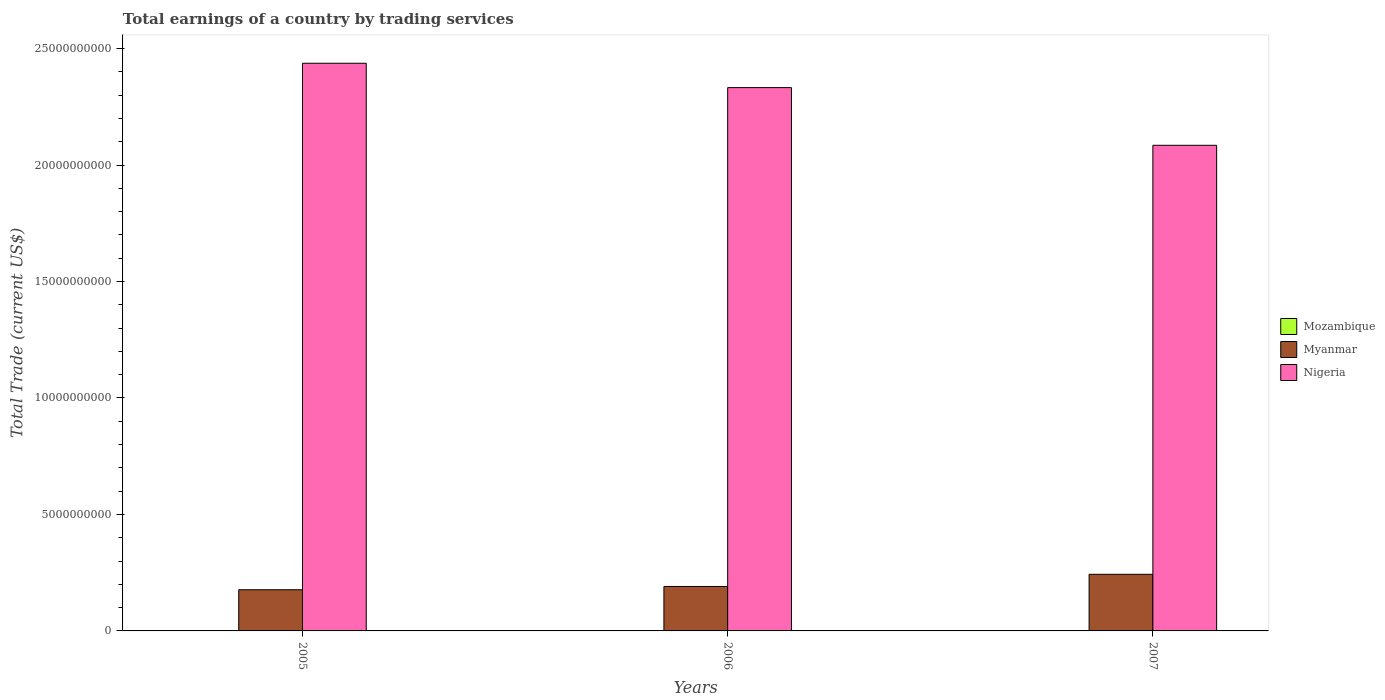How many different coloured bars are there?
Provide a succinct answer. 2. Are the number of bars per tick equal to the number of legend labels?
Provide a succinct answer. No. In how many cases, is the number of bars for a given year not equal to the number of legend labels?
Your response must be concise. 3. What is the total earnings in Myanmar in 2007?
Provide a short and direct response. 2.43e+09. Across all years, what is the maximum total earnings in Myanmar?
Make the answer very short. 2.43e+09. Across all years, what is the minimum total earnings in Myanmar?
Provide a short and direct response. 1.77e+09. In which year was the total earnings in Nigeria maximum?
Provide a succinct answer. 2005. What is the total total earnings in Myanmar in the graph?
Your response must be concise. 6.11e+09. What is the difference between the total earnings in Myanmar in 2005 and that in 2006?
Offer a terse response. -1.41e+08. What is the difference between the total earnings in Mozambique in 2007 and the total earnings in Myanmar in 2006?
Your response must be concise. -1.91e+09. What is the average total earnings in Myanmar per year?
Keep it short and to the point. 2.04e+09. In the year 2006, what is the difference between the total earnings in Nigeria and total earnings in Myanmar?
Provide a short and direct response. 2.14e+1. What is the ratio of the total earnings in Nigeria in 2006 to that in 2007?
Provide a succinct answer. 1.12. Is the total earnings in Nigeria in 2005 less than that in 2007?
Provide a short and direct response. No. Is the difference between the total earnings in Nigeria in 2005 and 2007 greater than the difference between the total earnings in Myanmar in 2005 and 2007?
Provide a succinct answer. Yes. What is the difference between the highest and the second highest total earnings in Myanmar?
Your answer should be very brief. 5.22e+08. What is the difference between the highest and the lowest total earnings in Myanmar?
Your answer should be compact. 6.63e+08. In how many years, is the total earnings in Nigeria greater than the average total earnings in Nigeria taken over all years?
Provide a succinct answer. 2. Is it the case that in every year, the sum of the total earnings in Myanmar and total earnings in Mozambique is greater than the total earnings in Nigeria?
Provide a short and direct response. No. How many bars are there?
Provide a short and direct response. 6. How many years are there in the graph?
Offer a terse response. 3. Are the values on the major ticks of Y-axis written in scientific E-notation?
Offer a very short reply. No. Does the graph contain any zero values?
Your answer should be very brief. Yes. What is the title of the graph?
Offer a terse response. Total earnings of a country by trading services. What is the label or title of the Y-axis?
Make the answer very short. Total Trade (current US$). What is the Total Trade (current US$) in Myanmar in 2005?
Provide a succinct answer. 1.77e+09. What is the Total Trade (current US$) in Nigeria in 2005?
Your response must be concise. 2.44e+1. What is the Total Trade (current US$) in Mozambique in 2006?
Provide a short and direct response. 0. What is the Total Trade (current US$) of Myanmar in 2006?
Provide a succinct answer. 1.91e+09. What is the Total Trade (current US$) of Nigeria in 2006?
Give a very brief answer. 2.33e+1. What is the Total Trade (current US$) of Mozambique in 2007?
Keep it short and to the point. 0. What is the Total Trade (current US$) in Myanmar in 2007?
Ensure brevity in your answer.  2.43e+09. What is the Total Trade (current US$) of Nigeria in 2007?
Keep it short and to the point. 2.08e+1. Across all years, what is the maximum Total Trade (current US$) of Myanmar?
Ensure brevity in your answer.  2.43e+09. Across all years, what is the maximum Total Trade (current US$) of Nigeria?
Provide a succinct answer. 2.44e+1. Across all years, what is the minimum Total Trade (current US$) of Myanmar?
Provide a succinct answer. 1.77e+09. Across all years, what is the minimum Total Trade (current US$) of Nigeria?
Make the answer very short. 2.08e+1. What is the total Total Trade (current US$) in Myanmar in the graph?
Your answer should be compact. 6.11e+09. What is the total Total Trade (current US$) in Nigeria in the graph?
Offer a terse response. 6.85e+1. What is the difference between the Total Trade (current US$) in Myanmar in 2005 and that in 2006?
Offer a terse response. -1.41e+08. What is the difference between the Total Trade (current US$) of Nigeria in 2005 and that in 2006?
Make the answer very short. 1.05e+09. What is the difference between the Total Trade (current US$) of Myanmar in 2005 and that in 2007?
Make the answer very short. -6.63e+08. What is the difference between the Total Trade (current US$) in Nigeria in 2005 and that in 2007?
Your answer should be compact. 3.52e+09. What is the difference between the Total Trade (current US$) of Myanmar in 2006 and that in 2007?
Give a very brief answer. -5.22e+08. What is the difference between the Total Trade (current US$) of Nigeria in 2006 and that in 2007?
Ensure brevity in your answer.  2.48e+09. What is the difference between the Total Trade (current US$) of Myanmar in 2005 and the Total Trade (current US$) of Nigeria in 2006?
Keep it short and to the point. -2.16e+1. What is the difference between the Total Trade (current US$) of Myanmar in 2005 and the Total Trade (current US$) of Nigeria in 2007?
Ensure brevity in your answer.  -1.91e+1. What is the difference between the Total Trade (current US$) of Myanmar in 2006 and the Total Trade (current US$) of Nigeria in 2007?
Provide a short and direct response. -1.89e+1. What is the average Total Trade (current US$) in Myanmar per year?
Keep it short and to the point. 2.04e+09. What is the average Total Trade (current US$) of Nigeria per year?
Your response must be concise. 2.28e+1. In the year 2005, what is the difference between the Total Trade (current US$) of Myanmar and Total Trade (current US$) of Nigeria?
Provide a short and direct response. -2.26e+1. In the year 2006, what is the difference between the Total Trade (current US$) of Myanmar and Total Trade (current US$) of Nigeria?
Your answer should be very brief. -2.14e+1. In the year 2007, what is the difference between the Total Trade (current US$) in Myanmar and Total Trade (current US$) in Nigeria?
Your answer should be compact. -1.84e+1. What is the ratio of the Total Trade (current US$) in Myanmar in 2005 to that in 2006?
Provide a short and direct response. 0.93. What is the ratio of the Total Trade (current US$) in Nigeria in 2005 to that in 2006?
Give a very brief answer. 1.04. What is the ratio of the Total Trade (current US$) of Myanmar in 2005 to that in 2007?
Make the answer very short. 0.73. What is the ratio of the Total Trade (current US$) of Nigeria in 2005 to that in 2007?
Offer a very short reply. 1.17. What is the ratio of the Total Trade (current US$) of Myanmar in 2006 to that in 2007?
Offer a very short reply. 0.79. What is the ratio of the Total Trade (current US$) in Nigeria in 2006 to that in 2007?
Keep it short and to the point. 1.12. What is the difference between the highest and the second highest Total Trade (current US$) of Myanmar?
Offer a very short reply. 5.22e+08. What is the difference between the highest and the second highest Total Trade (current US$) of Nigeria?
Provide a short and direct response. 1.05e+09. What is the difference between the highest and the lowest Total Trade (current US$) in Myanmar?
Give a very brief answer. 6.63e+08. What is the difference between the highest and the lowest Total Trade (current US$) in Nigeria?
Provide a short and direct response. 3.52e+09. 